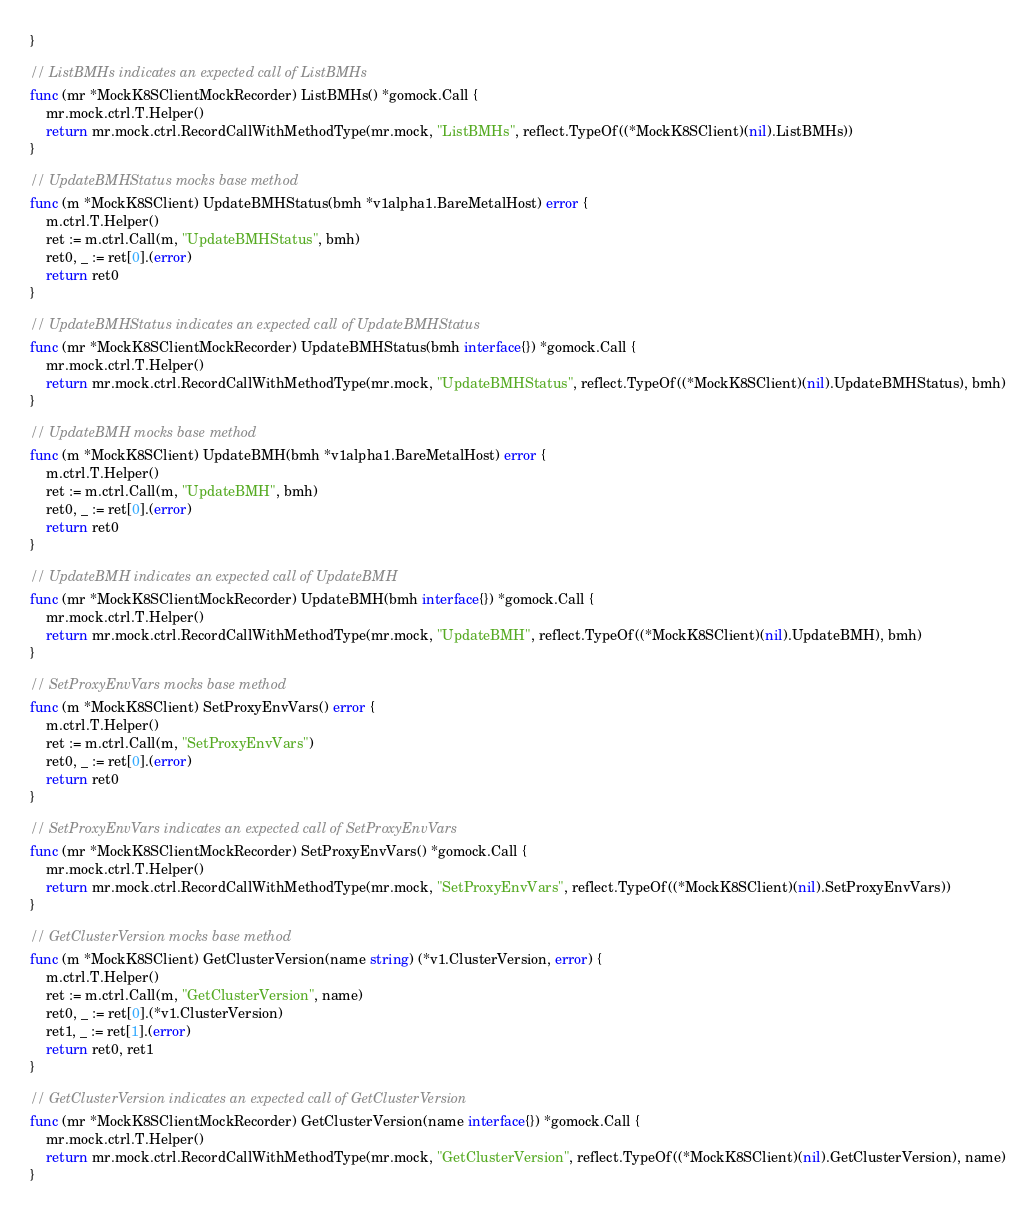<code> <loc_0><loc_0><loc_500><loc_500><_Go_>}

// ListBMHs indicates an expected call of ListBMHs
func (mr *MockK8SClientMockRecorder) ListBMHs() *gomock.Call {
	mr.mock.ctrl.T.Helper()
	return mr.mock.ctrl.RecordCallWithMethodType(mr.mock, "ListBMHs", reflect.TypeOf((*MockK8SClient)(nil).ListBMHs))
}

// UpdateBMHStatus mocks base method
func (m *MockK8SClient) UpdateBMHStatus(bmh *v1alpha1.BareMetalHost) error {
	m.ctrl.T.Helper()
	ret := m.ctrl.Call(m, "UpdateBMHStatus", bmh)
	ret0, _ := ret[0].(error)
	return ret0
}

// UpdateBMHStatus indicates an expected call of UpdateBMHStatus
func (mr *MockK8SClientMockRecorder) UpdateBMHStatus(bmh interface{}) *gomock.Call {
	mr.mock.ctrl.T.Helper()
	return mr.mock.ctrl.RecordCallWithMethodType(mr.mock, "UpdateBMHStatus", reflect.TypeOf((*MockK8SClient)(nil).UpdateBMHStatus), bmh)
}

// UpdateBMH mocks base method
func (m *MockK8SClient) UpdateBMH(bmh *v1alpha1.BareMetalHost) error {
	m.ctrl.T.Helper()
	ret := m.ctrl.Call(m, "UpdateBMH", bmh)
	ret0, _ := ret[0].(error)
	return ret0
}

// UpdateBMH indicates an expected call of UpdateBMH
func (mr *MockK8SClientMockRecorder) UpdateBMH(bmh interface{}) *gomock.Call {
	mr.mock.ctrl.T.Helper()
	return mr.mock.ctrl.RecordCallWithMethodType(mr.mock, "UpdateBMH", reflect.TypeOf((*MockK8SClient)(nil).UpdateBMH), bmh)
}

// SetProxyEnvVars mocks base method
func (m *MockK8SClient) SetProxyEnvVars() error {
	m.ctrl.T.Helper()
	ret := m.ctrl.Call(m, "SetProxyEnvVars")
	ret0, _ := ret[0].(error)
	return ret0
}

// SetProxyEnvVars indicates an expected call of SetProxyEnvVars
func (mr *MockK8SClientMockRecorder) SetProxyEnvVars() *gomock.Call {
	mr.mock.ctrl.T.Helper()
	return mr.mock.ctrl.RecordCallWithMethodType(mr.mock, "SetProxyEnvVars", reflect.TypeOf((*MockK8SClient)(nil).SetProxyEnvVars))
}

// GetClusterVersion mocks base method
func (m *MockK8SClient) GetClusterVersion(name string) (*v1.ClusterVersion, error) {
	m.ctrl.T.Helper()
	ret := m.ctrl.Call(m, "GetClusterVersion", name)
	ret0, _ := ret[0].(*v1.ClusterVersion)
	ret1, _ := ret[1].(error)
	return ret0, ret1
}

// GetClusterVersion indicates an expected call of GetClusterVersion
func (mr *MockK8SClientMockRecorder) GetClusterVersion(name interface{}) *gomock.Call {
	mr.mock.ctrl.T.Helper()
	return mr.mock.ctrl.RecordCallWithMethodType(mr.mock, "GetClusterVersion", reflect.TypeOf((*MockK8SClient)(nil).GetClusterVersion), name)
}
</code> 